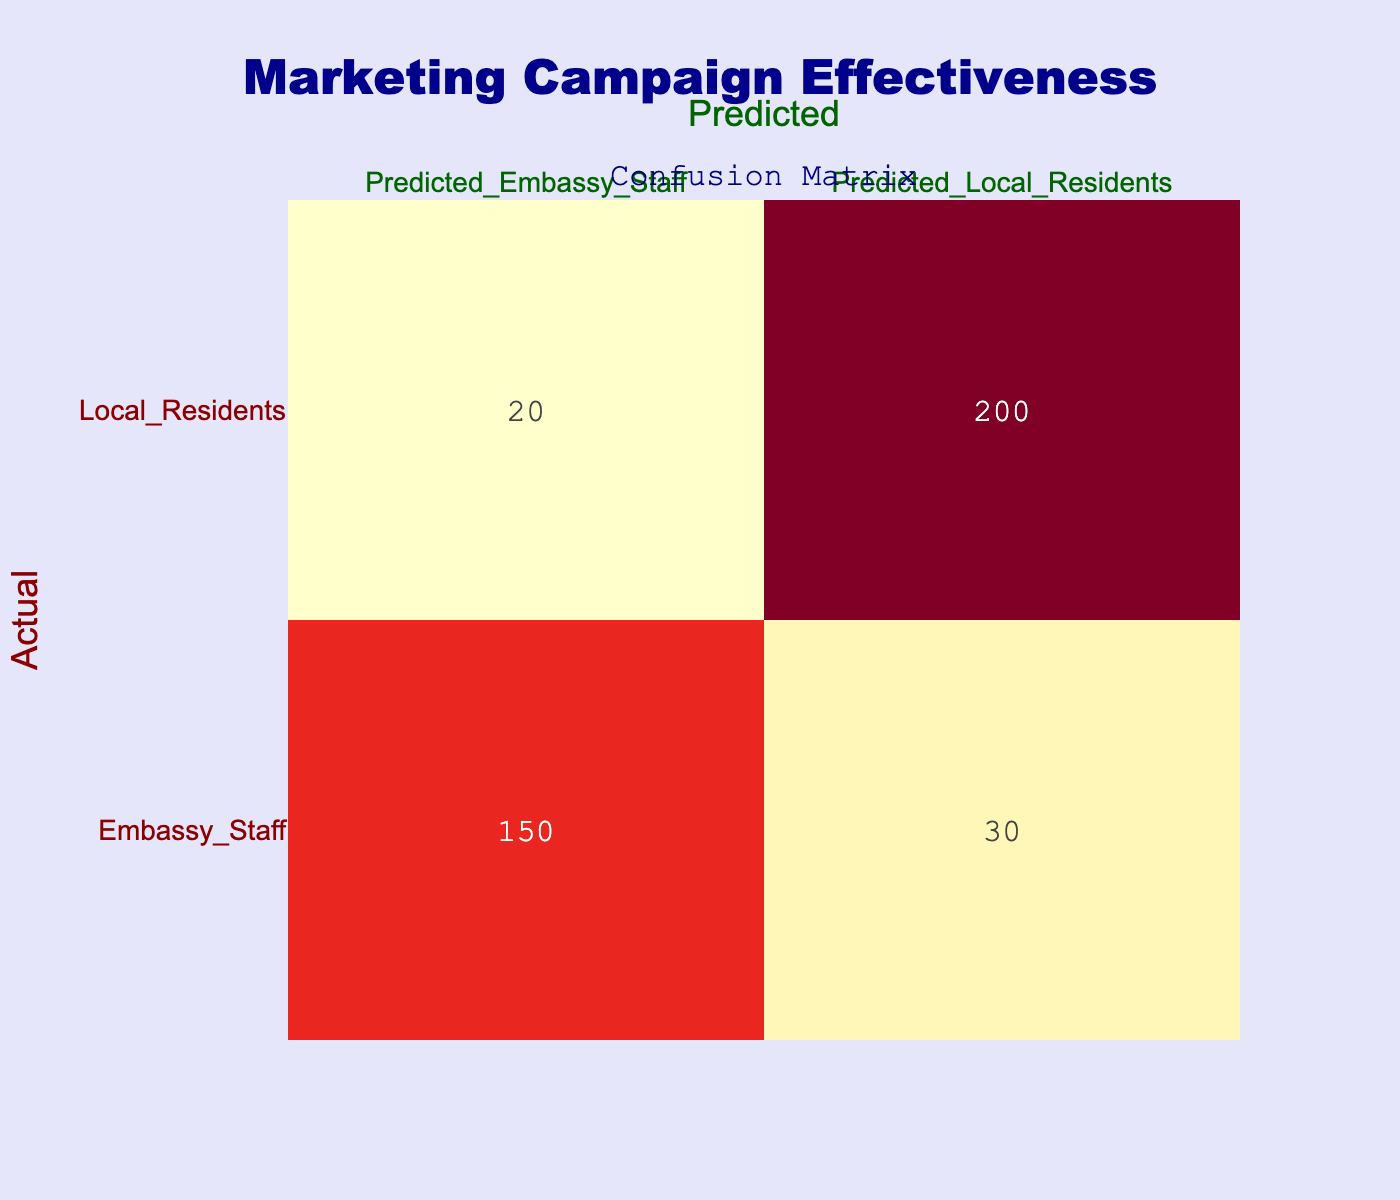What is the number of actual embassy staff predicted to be local residents? From the table, we can see there are 30 instances where actual embassy staff were incorrectly predicted to be local residents.
Answer: 30 What is the total number of actual local residents identified correctly? The table shows 200 actual local residents predicted correctly as local residents.
Answer: 200 What is the total combined number of embassy staff and local residents predicted as embassy staff? To find this, we need to add the predictions for embassy staff: 150 (actual embassy staff) + 20 (actual local residents). This sums up to 170.
Answer: 170 Does the marketing campaign seem more effective in attracting local residents or embassy staff? Looking at the table, the number of correctly predicted local residents (200) is much higher than the correctly predicted embassy staff (150), indicating higher effectiveness towards local residents.
Answer: Yes What is the accuracy of the predictions for embassy staff? To find the accuracy for embassy staff, we use the formula (True Positives + True Negatives) / Total instances. Here, True Positives (TP) are 150 and True Negatives (TN) are 200 (local residents predicted correctly), giving us (150 + 200) / (150 + 30 + 20 + 200) = 350 / 400 = 0.875 or 87.5%.
Answer: 87.5% How many total predictions were made for local residents? To find the total predictions for local residents, we sum the values in the local resident column: 30 (predicted embassy staff) + 200 (predicted local residents) = 230.
Answer: 230 What percentage of actual embassy staff were predicted correctly? To calculate the percentage, we take the number of correctly predicted embassy staff (150) divided by the total actual embassy staff (150 + 30 = 180), which gives us 150 / 180 = 0.833 or 83.3%.
Answer: 83.3% How many actual embassy staff were misclassified? To find the misclassified embassy staff, we look at the predicted local residents for embassy staff, which is 30.
Answer: 30 What percentage of all predictions was for local residents? The total predictions made for local residents is 230 and the total predictions made overall (150 + 30 + 20 + 200) is 400. Thus, the percentage is (230 / 400) * 100 = 57.5%.
Answer: 57.5% 